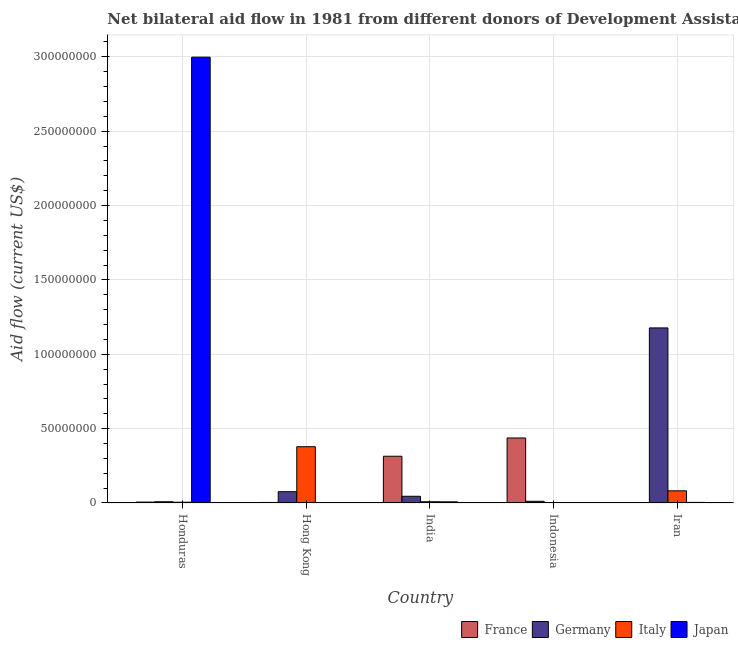How many groups of bars are there?
Provide a succinct answer. 5. How many bars are there on the 1st tick from the left?
Offer a very short reply. 4. How many bars are there on the 3rd tick from the right?
Offer a terse response. 4. What is the label of the 3rd group of bars from the left?
Offer a terse response. India. What is the amount of aid given by italy in Iran?
Provide a short and direct response. 8.18e+06. Across all countries, what is the maximum amount of aid given by france?
Keep it short and to the point. 4.37e+07. What is the total amount of aid given by japan in the graph?
Provide a succinct answer. 3.01e+08. What is the difference between the amount of aid given by italy in Hong Kong and that in Iran?
Give a very brief answer. 2.97e+07. What is the difference between the amount of aid given by italy in Iran and the amount of aid given by france in Indonesia?
Keep it short and to the point. -3.55e+07. What is the average amount of aid given by japan per country?
Ensure brevity in your answer.  6.02e+07. What is the difference between the amount of aid given by japan and amount of aid given by italy in Iran?
Make the answer very short. -7.76e+06. In how many countries, is the amount of aid given by japan greater than 10000000 US$?
Provide a succinct answer. 1. What is the ratio of the amount of aid given by germany in India to that in Indonesia?
Give a very brief answer. 3.96. Is the amount of aid given by germany in Honduras less than that in India?
Ensure brevity in your answer.  Yes. What is the difference between the highest and the second highest amount of aid given by germany?
Your response must be concise. 1.10e+08. What is the difference between the highest and the lowest amount of aid given by germany?
Make the answer very short. 1.17e+08. Is the sum of the amount of aid given by germany in Honduras and Indonesia greater than the maximum amount of aid given by france across all countries?
Offer a very short reply. No. Is it the case that in every country, the sum of the amount of aid given by germany and amount of aid given by italy is greater than the sum of amount of aid given by japan and amount of aid given by france?
Give a very brief answer. No. How many bars are there?
Offer a terse response. 17. Are all the bars in the graph horizontal?
Make the answer very short. No. Are the values on the major ticks of Y-axis written in scientific E-notation?
Keep it short and to the point. No. How many legend labels are there?
Give a very brief answer. 4. How are the legend labels stacked?
Provide a succinct answer. Horizontal. What is the title of the graph?
Keep it short and to the point. Net bilateral aid flow in 1981 from different donors of Development Assistance Committee. Does "Secondary general education" appear as one of the legend labels in the graph?
Your answer should be compact. No. What is the Aid flow (current US$) of Germany in Honduras?
Offer a terse response. 8.40e+05. What is the Aid flow (current US$) in Italy in Honduras?
Provide a succinct answer. 5.10e+05. What is the Aid flow (current US$) in Japan in Honduras?
Give a very brief answer. 3.00e+08. What is the Aid flow (current US$) of France in Hong Kong?
Ensure brevity in your answer.  3.70e+05. What is the Aid flow (current US$) of Germany in Hong Kong?
Offer a very short reply. 7.60e+06. What is the Aid flow (current US$) in Italy in Hong Kong?
Ensure brevity in your answer.  3.78e+07. What is the Aid flow (current US$) of Japan in Hong Kong?
Offer a terse response. 0. What is the Aid flow (current US$) of France in India?
Your answer should be compact. 3.14e+07. What is the Aid flow (current US$) in Germany in India?
Provide a succinct answer. 4.52e+06. What is the Aid flow (current US$) in Italy in India?
Offer a terse response. 8.50e+05. What is the Aid flow (current US$) of Japan in India?
Your response must be concise. 7.80e+05. What is the Aid flow (current US$) of France in Indonesia?
Ensure brevity in your answer.  4.37e+07. What is the Aid flow (current US$) of Germany in Indonesia?
Ensure brevity in your answer.  1.14e+06. What is the Aid flow (current US$) in Italy in Indonesia?
Provide a short and direct response. 0. What is the Aid flow (current US$) in Germany in Iran?
Make the answer very short. 1.18e+08. What is the Aid flow (current US$) of Italy in Iran?
Offer a terse response. 8.18e+06. Across all countries, what is the maximum Aid flow (current US$) in France?
Make the answer very short. 4.37e+07. Across all countries, what is the maximum Aid flow (current US$) of Germany?
Offer a very short reply. 1.18e+08. Across all countries, what is the maximum Aid flow (current US$) of Italy?
Provide a succinct answer. 3.78e+07. Across all countries, what is the maximum Aid flow (current US$) of Japan?
Give a very brief answer. 3.00e+08. Across all countries, what is the minimum Aid flow (current US$) of France?
Keep it short and to the point. 0. Across all countries, what is the minimum Aid flow (current US$) of Germany?
Offer a very short reply. 8.40e+05. Across all countries, what is the minimum Aid flow (current US$) in Italy?
Ensure brevity in your answer.  0. Across all countries, what is the minimum Aid flow (current US$) in Japan?
Your answer should be very brief. 0. What is the total Aid flow (current US$) of France in the graph?
Make the answer very short. 7.61e+07. What is the total Aid flow (current US$) of Germany in the graph?
Your response must be concise. 1.32e+08. What is the total Aid flow (current US$) of Italy in the graph?
Keep it short and to the point. 4.74e+07. What is the total Aid flow (current US$) in Japan in the graph?
Provide a succinct answer. 3.01e+08. What is the difference between the Aid flow (current US$) in France in Honduras and that in Hong Kong?
Make the answer very short. 2.40e+05. What is the difference between the Aid flow (current US$) in Germany in Honduras and that in Hong Kong?
Your answer should be very brief. -6.76e+06. What is the difference between the Aid flow (current US$) in Italy in Honduras and that in Hong Kong?
Your answer should be very brief. -3.73e+07. What is the difference between the Aid flow (current US$) of France in Honduras and that in India?
Provide a short and direct response. -3.08e+07. What is the difference between the Aid flow (current US$) in Germany in Honduras and that in India?
Keep it short and to the point. -3.68e+06. What is the difference between the Aid flow (current US$) in Italy in Honduras and that in India?
Provide a succinct answer. -3.40e+05. What is the difference between the Aid flow (current US$) of Japan in Honduras and that in India?
Ensure brevity in your answer.  2.99e+08. What is the difference between the Aid flow (current US$) of France in Honduras and that in Indonesia?
Offer a very short reply. -4.31e+07. What is the difference between the Aid flow (current US$) in Japan in Honduras and that in Indonesia?
Offer a very short reply. 3.00e+08. What is the difference between the Aid flow (current US$) of Germany in Honduras and that in Iran?
Keep it short and to the point. -1.17e+08. What is the difference between the Aid flow (current US$) of Italy in Honduras and that in Iran?
Ensure brevity in your answer.  -7.67e+06. What is the difference between the Aid flow (current US$) of Japan in Honduras and that in Iran?
Offer a very short reply. 2.99e+08. What is the difference between the Aid flow (current US$) in France in Hong Kong and that in India?
Your response must be concise. -3.11e+07. What is the difference between the Aid flow (current US$) of Germany in Hong Kong and that in India?
Offer a terse response. 3.08e+06. What is the difference between the Aid flow (current US$) in Italy in Hong Kong and that in India?
Provide a succinct answer. 3.70e+07. What is the difference between the Aid flow (current US$) of France in Hong Kong and that in Indonesia?
Your answer should be compact. -4.34e+07. What is the difference between the Aid flow (current US$) in Germany in Hong Kong and that in Indonesia?
Provide a succinct answer. 6.46e+06. What is the difference between the Aid flow (current US$) of Germany in Hong Kong and that in Iran?
Ensure brevity in your answer.  -1.10e+08. What is the difference between the Aid flow (current US$) in Italy in Hong Kong and that in Iran?
Offer a terse response. 2.97e+07. What is the difference between the Aid flow (current US$) of France in India and that in Indonesia?
Give a very brief answer. -1.23e+07. What is the difference between the Aid flow (current US$) in Germany in India and that in Indonesia?
Your answer should be compact. 3.38e+06. What is the difference between the Aid flow (current US$) in Japan in India and that in Indonesia?
Keep it short and to the point. 6.90e+05. What is the difference between the Aid flow (current US$) in Germany in India and that in Iran?
Provide a short and direct response. -1.13e+08. What is the difference between the Aid flow (current US$) in Italy in India and that in Iran?
Offer a very short reply. -7.33e+06. What is the difference between the Aid flow (current US$) in Japan in India and that in Iran?
Give a very brief answer. 3.60e+05. What is the difference between the Aid flow (current US$) of Germany in Indonesia and that in Iran?
Offer a terse response. -1.17e+08. What is the difference between the Aid flow (current US$) in Japan in Indonesia and that in Iran?
Your answer should be very brief. -3.30e+05. What is the difference between the Aid flow (current US$) in France in Honduras and the Aid flow (current US$) in Germany in Hong Kong?
Offer a very short reply. -6.99e+06. What is the difference between the Aid flow (current US$) of France in Honduras and the Aid flow (current US$) of Italy in Hong Kong?
Offer a terse response. -3.72e+07. What is the difference between the Aid flow (current US$) of Germany in Honduras and the Aid flow (current US$) of Italy in Hong Kong?
Your answer should be very brief. -3.70e+07. What is the difference between the Aid flow (current US$) in France in Honduras and the Aid flow (current US$) in Germany in India?
Give a very brief answer. -3.91e+06. What is the difference between the Aid flow (current US$) of Germany in Honduras and the Aid flow (current US$) of Italy in India?
Provide a succinct answer. -10000. What is the difference between the Aid flow (current US$) in Italy in Honduras and the Aid flow (current US$) in Japan in India?
Provide a short and direct response. -2.70e+05. What is the difference between the Aid flow (current US$) in France in Honduras and the Aid flow (current US$) in Germany in Indonesia?
Make the answer very short. -5.30e+05. What is the difference between the Aid flow (current US$) in France in Honduras and the Aid flow (current US$) in Japan in Indonesia?
Ensure brevity in your answer.  5.20e+05. What is the difference between the Aid flow (current US$) of Germany in Honduras and the Aid flow (current US$) of Japan in Indonesia?
Provide a short and direct response. 7.50e+05. What is the difference between the Aid flow (current US$) in Italy in Honduras and the Aid flow (current US$) in Japan in Indonesia?
Keep it short and to the point. 4.20e+05. What is the difference between the Aid flow (current US$) of France in Honduras and the Aid flow (current US$) of Germany in Iran?
Ensure brevity in your answer.  -1.17e+08. What is the difference between the Aid flow (current US$) in France in Honduras and the Aid flow (current US$) in Italy in Iran?
Provide a succinct answer. -7.57e+06. What is the difference between the Aid flow (current US$) in France in Honduras and the Aid flow (current US$) in Japan in Iran?
Provide a succinct answer. 1.90e+05. What is the difference between the Aid flow (current US$) in Germany in Honduras and the Aid flow (current US$) in Italy in Iran?
Ensure brevity in your answer.  -7.34e+06. What is the difference between the Aid flow (current US$) in Italy in Honduras and the Aid flow (current US$) in Japan in Iran?
Offer a very short reply. 9.00e+04. What is the difference between the Aid flow (current US$) in France in Hong Kong and the Aid flow (current US$) in Germany in India?
Provide a short and direct response. -4.15e+06. What is the difference between the Aid flow (current US$) of France in Hong Kong and the Aid flow (current US$) of Italy in India?
Your answer should be very brief. -4.80e+05. What is the difference between the Aid flow (current US$) in France in Hong Kong and the Aid flow (current US$) in Japan in India?
Your answer should be very brief. -4.10e+05. What is the difference between the Aid flow (current US$) in Germany in Hong Kong and the Aid flow (current US$) in Italy in India?
Your response must be concise. 6.75e+06. What is the difference between the Aid flow (current US$) in Germany in Hong Kong and the Aid flow (current US$) in Japan in India?
Provide a succinct answer. 6.82e+06. What is the difference between the Aid flow (current US$) in Italy in Hong Kong and the Aid flow (current US$) in Japan in India?
Make the answer very short. 3.71e+07. What is the difference between the Aid flow (current US$) of France in Hong Kong and the Aid flow (current US$) of Germany in Indonesia?
Give a very brief answer. -7.70e+05. What is the difference between the Aid flow (current US$) in Germany in Hong Kong and the Aid flow (current US$) in Japan in Indonesia?
Your answer should be very brief. 7.51e+06. What is the difference between the Aid flow (current US$) in Italy in Hong Kong and the Aid flow (current US$) in Japan in Indonesia?
Provide a succinct answer. 3.78e+07. What is the difference between the Aid flow (current US$) in France in Hong Kong and the Aid flow (current US$) in Germany in Iran?
Keep it short and to the point. -1.17e+08. What is the difference between the Aid flow (current US$) of France in Hong Kong and the Aid flow (current US$) of Italy in Iran?
Make the answer very short. -7.81e+06. What is the difference between the Aid flow (current US$) in France in Hong Kong and the Aid flow (current US$) in Japan in Iran?
Offer a terse response. -5.00e+04. What is the difference between the Aid flow (current US$) of Germany in Hong Kong and the Aid flow (current US$) of Italy in Iran?
Your answer should be compact. -5.80e+05. What is the difference between the Aid flow (current US$) in Germany in Hong Kong and the Aid flow (current US$) in Japan in Iran?
Provide a succinct answer. 7.18e+06. What is the difference between the Aid flow (current US$) of Italy in Hong Kong and the Aid flow (current US$) of Japan in Iran?
Your response must be concise. 3.74e+07. What is the difference between the Aid flow (current US$) of France in India and the Aid flow (current US$) of Germany in Indonesia?
Provide a short and direct response. 3.03e+07. What is the difference between the Aid flow (current US$) in France in India and the Aid flow (current US$) in Japan in Indonesia?
Keep it short and to the point. 3.13e+07. What is the difference between the Aid flow (current US$) of Germany in India and the Aid flow (current US$) of Japan in Indonesia?
Offer a very short reply. 4.43e+06. What is the difference between the Aid flow (current US$) of Italy in India and the Aid flow (current US$) of Japan in Indonesia?
Provide a succinct answer. 7.60e+05. What is the difference between the Aid flow (current US$) in France in India and the Aid flow (current US$) in Germany in Iran?
Offer a terse response. -8.63e+07. What is the difference between the Aid flow (current US$) of France in India and the Aid flow (current US$) of Italy in Iran?
Provide a short and direct response. 2.32e+07. What is the difference between the Aid flow (current US$) of France in India and the Aid flow (current US$) of Japan in Iran?
Keep it short and to the point. 3.10e+07. What is the difference between the Aid flow (current US$) of Germany in India and the Aid flow (current US$) of Italy in Iran?
Your answer should be compact. -3.66e+06. What is the difference between the Aid flow (current US$) of Germany in India and the Aid flow (current US$) of Japan in Iran?
Ensure brevity in your answer.  4.10e+06. What is the difference between the Aid flow (current US$) in Italy in India and the Aid flow (current US$) in Japan in Iran?
Offer a terse response. 4.30e+05. What is the difference between the Aid flow (current US$) in France in Indonesia and the Aid flow (current US$) in Germany in Iran?
Provide a succinct answer. -7.40e+07. What is the difference between the Aid flow (current US$) in France in Indonesia and the Aid flow (current US$) in Italy in Iran?
Your answer should be compact. 3.55e+07. What is the difference between the Aid flow (current US$) in France in Indonesia and the Aid flow (current US$) in Japan in Iran?
Offer a terse response. 4.33e+07. What is the difference between the Aid flow (current US$) in Germany in Indonesia and the Aid flow (current US$) in Italy in Iran?
Provide a succinct answer. -7.04e+06. What is the difference between the Aid flow (current US$) of Germany in Indonesia and the Aid flow (current US$) of Japan in Iran?
Ensure brevity in your answer.  7.20e+05. What is the average Aid flow (current US$) of France per country?
Give a very brief answer. 1.52e+07. What is the average Aid flow (current US$) of Germany per country?
Your response must be concise. 2.64e+07. What is the average Aid flow (current US$) of Italy per country?
Offer a very short reply. 9.48e+06. What is the average Aid flow (current US$) of Japan per country?
Keep it short and to the point. 6.02e+07. What is the difference between the Aid flow (current US$) of France and Aid flow (current US$) of Japan in Honduras?
Your response must be concise. -2.99e+08. What is the difference between the Aid flow (current US$) in Germany and Aid flow (current US$) in Japan in Honduras?
Provide a succinct answer. -2.99e+08. What is the difference between the Aid flow (current US$) in Italy and Aid flow (current US$) in Japan in Honduras?
Keep it short and to the point. -2.99e+08. What is the difference between the Aid flow (current US$) in France and Aid flow (current US$) in Germany in Hong Kong?
Your response must be concise. -7.23e+06. What is the difference between the Aid flow (current US$) of France and Aid flow (current US$) of Italy in Hong Kong?
Keep it short and to the point. -3.75e+07. What is the difference between the Aid flow (current US$) in Germany and Aid flow (current US$) in Italy in Hong Kong?
Keep it short and to the point. -3.02e+07. What is the difference between the Aid flow (current US$) of France and Aid flow (current US$) of Germany in India?
Keep it short and to the point. 2.69e+07. What is the difference between the Aid flow (current US$) of France and Aid flow (current US$) of Italy in India?
Offer a terse response. 3.06e+07. What is the difference between the Aid flow (current US$) in France and Aid flow (current US$) in Japan in India?
Offer a very short reply. 3.06e+07. What is the difference between the Aid flow (current US$) in Germany and Aid flow (current US$) in Italy in India?
Your answer should be very brief. 3.67e+06. What is the difference between the Aid flow (current US$) of Germany and Aid flow (current US$) of Japan in India?
Your answer should be very brief. 3.74e+06. What is the difference between the Aid flow (current US$) of France and Aid flow (current US$) of Germany in Indonesia?
Offer a terse response. 4.26e+07. What is the difference between the Aid flow (current US$) of France and Aid flow (current US$) of Japan in Indonesia?
Your response must be concise. 4.36e+07. What is the difference between the Aid flow (current US$) in Germany and Aid flow (current US$) in Japan in Indonesia?
Provide a succinct answer. 1.05e+06. What is the difference between the Aid flow (current US$) of Germany and Aid flow (current US$) of Italy in Iran?
Keep it short and to the point. 1.10e+08. What is the difference between the Aid flow (current US$) in Germany and Aid flow (current US$) in Japan in Iran?
Provide a short and direct response. 1.17e+08. What is the difference between the Aid flow (current US$) of Italy and Aid flow (current US$) of Japan in Iran?
Offer a very short reply. 7.76e+06. What is the ratio of the Aid flow (current US$) in France in Honduras to that in Hong Kong?
Make the answer very short. 1.65. What is the ratio of the Aid flow (current US$) in Germany in Honduras to that in Hong Kong?
Offer a very short reply. 0.11. What is the ratio of the Aid flow (current US$) in Italy in Honduras to that in Hong Kong?
Provide a succinct answer. 0.01. What is the ratio of the Aid flow (current US$) of France in Honduras to that in India?
Make the answer very short. 0.02. What is the ratio of the Aid flow (current US$) in Germany in Honduras to that in India?
Keep it short and to the point. 0.19. What is the ratio of the Aid flow (current US$) in Italy in Honduras to that in India?
Your response must be concise. 0.6. What is the ratio of the Aid flow (current US$) of Japan in Honduras to that in India?
Give a very brief answer. 384.36. What is the ratio of the Aid flow (current US$) in France in Honduras to that in Indonesia?
Make the answer very short. 0.01. What is the ratio of the Aid flow (current US$) of Germany in Honduras to that in Indonesia?
Your answer should be compact. 0.74. What is the ratio of the Aid flow (current US$) in Japan in Honduras to that in Indonesia?
Your answer should be very brief. 3331.11. What is the ratio of the Aid flow (current US$) of Germany in Honduras to that in Iran?
Keep it short and to the point. 0.01. What is the ratio of the Aid flow (current US$) of Italy in Honduras to that in Iran?
Provide a short and direct response. 0.06. What is the ratio of the Aid flow (current US$) of Japan in Honduras to that in Iran?
Give a very brief answer. 713.81. What is the ratio of the Aid flow (current US$) in France in Hong Kong to that in India?
Provide a short and direct response. 0.01. What is the ratio of the Aid flow (current US$) in Germany in Hong Kong to that in India?
Ensure brevity in your answer.  1.68. What is the ratio of the Aid flow (current US$) of Italy in Hong Kong to that in India?
Keep it short and to the point. 44.52. What is the ratio of the Aid flow (current US$) of France in Hong Kong to that in Indonesia?
Provide a succinct answer. 0.01. What is the ratio of the Aid flow (current US$) of Germany in Hong Kong to that in Indonesia?
Give a very brief answer. 6.67. What is the ratio of the Aid flow (current US$) in Germany in Hong Kong to that in Iran?
Your answer should be very brief. 0.06. What is the ratio of the Aid flow (current US$) in Italy in Hong Kong to that in Iran?
Ensure brevity in your answer.  4.63. What is the ratio of the Aid flow (current US$) of France in India to that in Indonesia?
Give a very brief answer. 0.72. What is the ratio of the Aid flow (current US$) in Germany in India to that in Indonesia?
Offer a terse response. 3.96. What is the ratio of the Aid flow (current US$) in Japan in India to that in Indonesia?
Your answer should be very brief. 8.67. What is the ratio of the Aid flow (current US$) of Germany in India to that in Iran?
Make the answer very short. 0.04. What is the ratio of the Aid flow (current US$) of Italy in India to that in Iran?
Offer a terse response. 0.1. What is the ratio of the Aid flow (current US$) of Japan in India to that in Iran?
Provide a short and direct response. 1.86. What is the ratio of the Aid flow (current US$) in Germany in Indonesia to that in Iran?
Your answer should be very brief. 0.01. What is the ratio of the Aid flow (current US$) in Japan in Indonesia to that in Iran?
Ensure brevity in your answer.  0.21. What is the difference between the highest and the second highest Aid flow (current US$) in France?
Your answer should be compact. 1.23e+07. What is the difference between the highest and the second highest Aid flow (current US$) of Germany?
Offer a terse response. 1.10e+08. What is the difference between the highest and the second highest Aid flow (current US$) in Italy?
Make the answer very short. 2.97e+07. What is the difference between the highest and the second highest Aid flow (current US$) in Japan?
Ensure brevity in your answer.  2.99e+08. What is the difference between the highest and the lowest Aid flow (current US$) in France?
Provide a succinct answer. 4.37e+07. What is the difference between the highest and the lowest Aid flow (current US$) in Germany?
Provide a succinct answer. 1.17e+08. What is the difference between the highest and the lowest Aid flow (current US$) of Italy?
Give a very brief answer. 3.78e+07. What is the difference between the highest and the lowest Aid flow (current US$) in Japan?
Your answer should be very brief. 3.00e+08. 